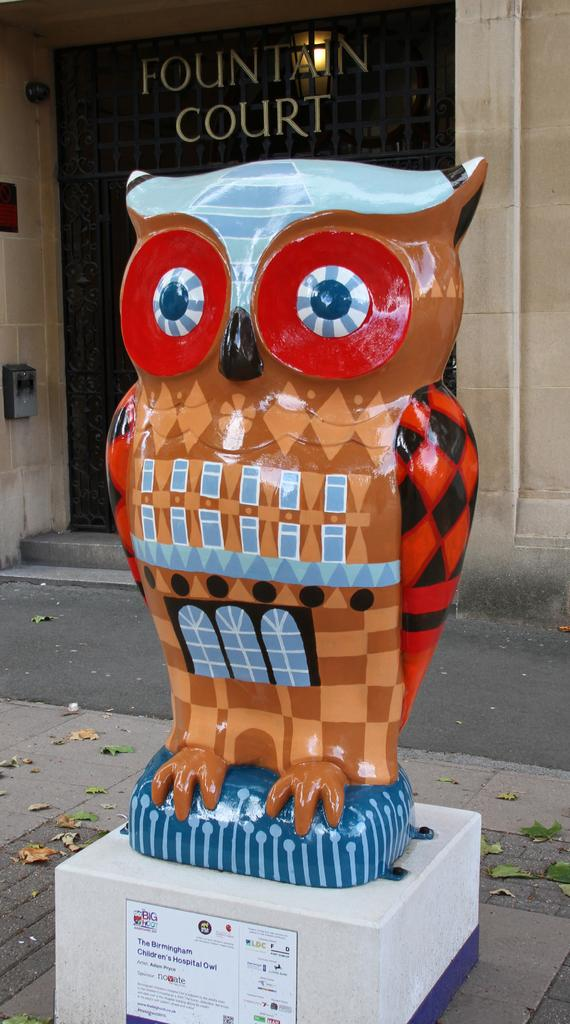What is the main subject of the image? The main subject of the image is a statue of an owl. Can you describe the statue's location in the image? The statue of the owl is in front of a building in the image. What type of cap is the fairy wearing in the image? There are no fairies or caps present in the image; it features a statue of an owl and a building. Is the gun visible in the image? There is no gun present in the image. 